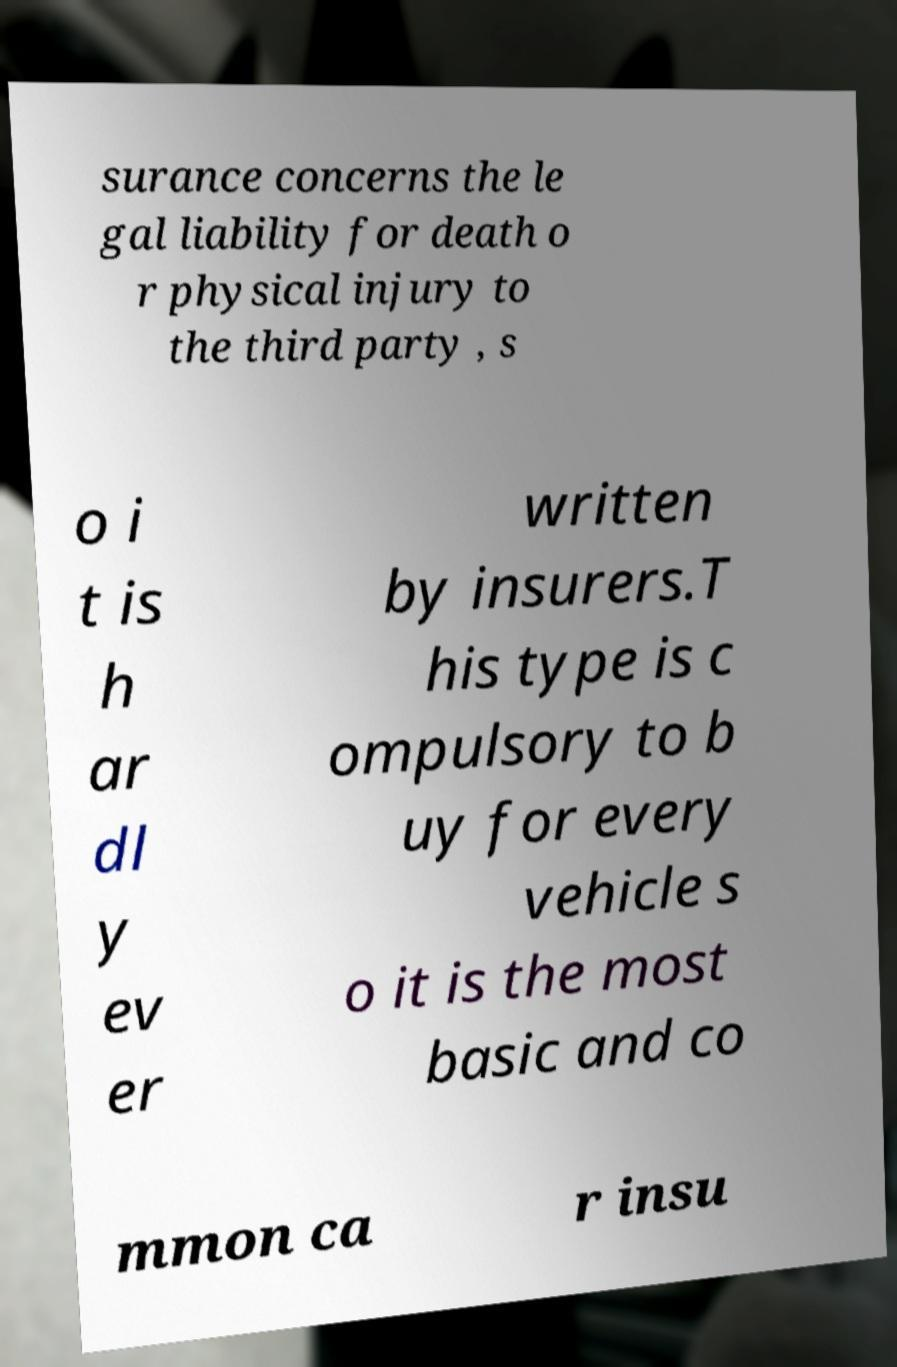For documentation purposes, I need the text within this image transcribed. Could you provide that? surance concerns the le gal liability for death o r physical injury to the third party , s o i t is h ar dl y ev er written by insurers.T his type is c ompulsory to b uy for every vehicle s o it is the most basic and co mmon ca r insu 